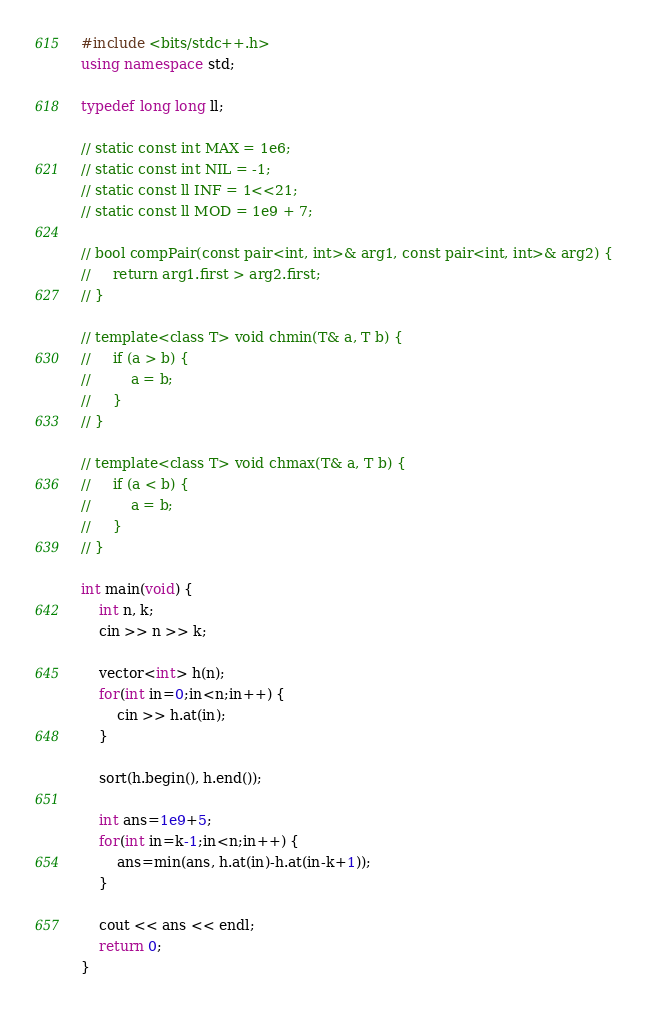<code> <loc_0><loc_0><loc_500><loc_500><_C++_>#include <bits/stdc++.h>
using namespace std;

typedef long long ll;

// static const int MAX = 1e6;
// static const int NIL = -1;
// static const ll INF = 1<<21;
// static const ll MOD = 1e9 + 7;

// bool compPair(const pair<int, int>& arg1, const pair<int, int>& arg2) {
//     return arg1.first > arg2.first;
// }

// template<class T> void chmin(T& a, T b) {
//     if (a > b) {
//         a = b;
//     }
// }

// template<class T> void chmax(T& a, T b) {
//     if (a < b) {
//         a = b;
//     }
// }

int main(void) {
    int n, k;
    cin >> n >> k;

    vector<int> h(n);
    for(int in=0;in<n;in++) {
        cin >> h.at(in);
    }

    sort(h.begin(), h.end());

    int ans=1e9+5;
    for(int in=k-1;in<n;in++) {
        ans=min(ans, h.at(in)-h.at(in-k+1));
    }

    cout << ans << endl;
    return 0;
}
</code> 